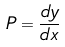Convert formula to latex. <formula><loc_0><loc_0><loc_500><loc_500>P = \frac { d y } { d x }</formula> 